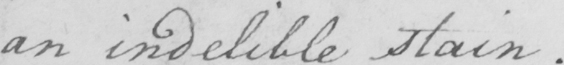Please transcribe the handwritten text in this image. an indelible stain. 